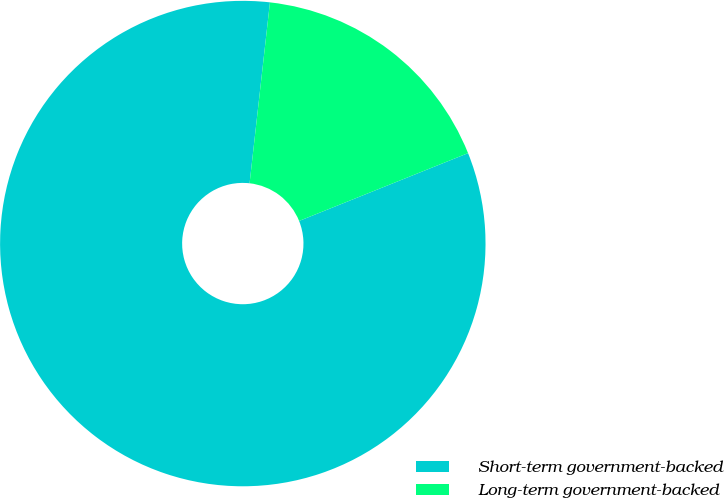Convert chart to OTSL. <chart><loc_0><loc_0><loc_500><loc_500><pie_chart><fcel>Short-term government-backed<fcel>Long-term government-backed<nl><fcel>82.86%<fcel>17.14%<nl></chart> 